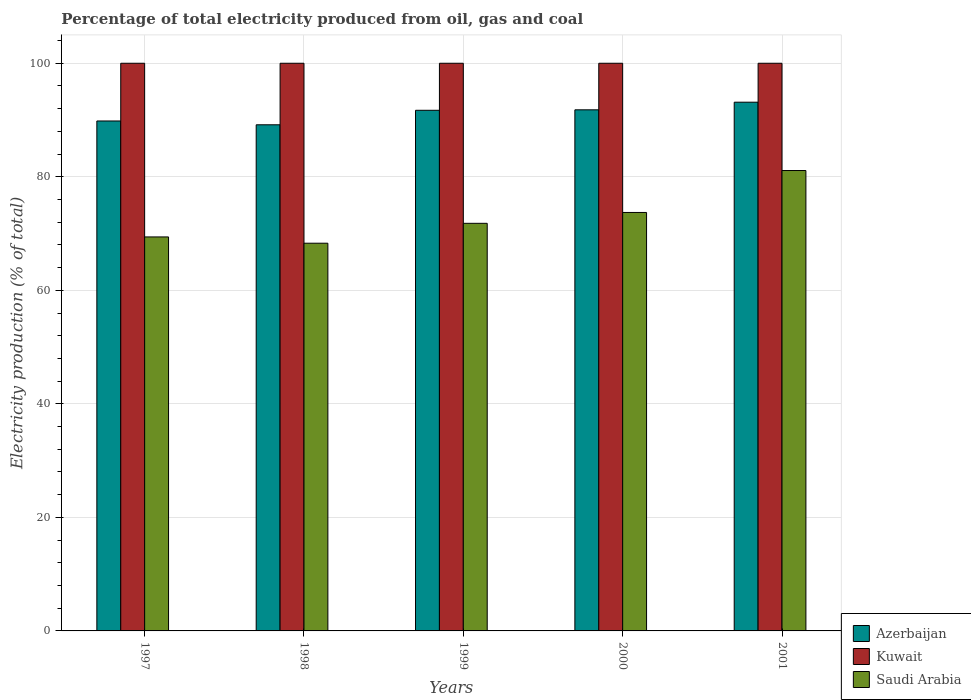How many different coloured bars are there?
Your answer should be very brief. 3. Are the number of bars on each tick of the X-axis equal?
Give a very brief answer. Yes. How many bars are there on the 2nd tick from the right?
Your answer should be compact. 3. What is the electricity production in in Azerbaijan in 1998?
Your answer should be very brief. 89.16. Across all years, what is the maximum electricity production in in Azerbaijan?
Provide a succinct answer. 93.14. Across all years, what is the minimum electricity production in in Azerbaijan?
Your answer should be very brief. 89.16. In which year was the electricity production in in Saudi Arabia maximum?
Give a very brief answer. 2001. In which year was the electricity production in in Azerbaijan minimum?
Your answer should be very brief. 1998. What is the total electricity production in in Saudi Arabia in the graph?
Offer a terse response. 364.33. What is the difference between the electricity production in in Saudi Arabia in 1997 and that in 1998?
Keep it short and to the point. 1.11. What is the difference between the electricity production in in Saudi Arabia in 1997 and the electricity production in in Azerbaijan in 1999?
Your response must be concise. -22.31. In the year 2000, what is the difference between the electricity production in in Azerbaijan and electricity production in in Saudi Arabia?
Ensure brevity in your answer.  18.08. In how many years, is the electricity production in in Saudi Arabia greater than 60 %?
Give a very brief answer. 5. What is the ratio of the electricity production in in Azerbaijan in 1999 to that in 2001?
Make the answer very short. 0.98. Is the difference between the electricity production in in Azerbaijan in 1999 and 2001 greater than the difference between the electricity production in in Saudi Arabia in 1999 and 2001?
Make the answer very short. Yes. What is the difference between the highest and the second highest electricity production in in Saudi Arabia?
Ensure brevity in your answer.  7.39. What is the difference between the highest and the lowest electricity production in in Kuwait?
Offer a terse response. 0. In how many years, is the electricity production in in Azerbaijan greater than the average electricity production in in Azerbaijan taken over all years?
Offer a very short reply. 3. What does the 3rd bar from the left in 1998 represents?
Your answer should be very brief. Saudi Arabia. What does the 2nd bar from the right in 2001 represents?
Keep it short and to the point. Kuwait. How many bars are there?
Ensure brevity in your answer.  15. How many years are there in the graph?
Make the answer very short. 5. Does the graph contain any zero values?
Provide a succinct answer. No. Does the graph contain grids?
Ensure brevity in your answer.  Yes. How are the legend labels stacked?
Offer a very short reply. Vertical. What is the title of the graph?
Your response must be concise. Percentage of total electricity produced from oil, gas and coal. What is the label or title of the X-axis?
Make the answer very short. Years. What is the label or title of the Y-axis?
Make the answer very short. Electricity production (% of total). What is the Electricity production (% of total) in Azerbaijan in 1997?
Ensure brevity in your answer.  89.83. What is the Electricity production (% of total) of Saudi Arabia in 1997?
Make the answer very short. 69.41. What is the Electricity production (% of total) of Azerbaijan in 1998?
Provide a short and direct response. 89.16. What is the Electricity production (% of total) in Saudi Arabia in 1998?
Make the answer very short. 68.3. What is the Electricity production (% of total) of Azerbaijan in 1999?
Offer a terse response. 91.71. What is the Electricity production (% of total) in Saudi Arabia in 1999?
Provide a short and direct response. 71.8. What is the Electricity production (% of total) in Azerbaijan in 2000?
Your response must be concise. 91.8. What is the Electricity production (% of total) in Kuwait in 2000?
Offer a very short reply. 100. What is the Electricity production (% of total) of Saudi Arabia in 2000?
Ensure brevity in your answer.  73.72. What is the Electricity production (% of total) of Azerbaijan in 2001?
Your response must be concise. 93.14. What is the Electricity production (% of total) in Saudi Arabia in 2001?
Keep it short and to the point. 81.11. Across all years, what is the maximum Electricity production (% of total) of Azerbaijan?
Give a very brief answer. 93.14. Across all years, what is the maximum Electricity production (% of total) in Kuwait?
Your response must be concise. 100. Across all years, what is the maximum Electricity production (% of total) of Saudi Arabia?
Offer a very short reply. 81.11. Across all years, what is the minimum Electricity production (% of total) in Azerbaijan?
Offer a very short reply. 89.16. Across all years, what is the minimum Electricity production (% of total) of Saudi Arabia?
Your answer should be very brief. 68.3. What is the total Electricity production (% of total) of Azerbaijan in the graph?
Give a very brief answer. 455.64. What is the total Electricity production (% of total) in Saudi Arabia in the graph?
Your answer should be compact. 364.33. What is the difference between the Electricity production (% of total) in Azerbaijan in 1997 and that in 1998?
Your answer should be very brief. 0.67. What is the difference between the Electricity production (% of total) of Saudi Arabia in 1997 and that in 1998?
Your answer should be compact. 1.11. What is the difference between the Electricity production (% of total) of Azerbaijan in 1997 and that in 1999?
Keep it short and to the point. -1.88. What is the difference between the Electricity production (% of total) in Kuwait in 1997 and that in 1999?
Your answer should be compact. 0. What is the difference between the Electricity production (% of total) in Saudi Arabia in 1997 and that in 1999?
Keep it short and to the point. -2.4. What is the difference between the Electricity production (% of total) in Azerbaijan in 1997 and that in 2000?
Make the answer very short. -1.97. What is the difference between the Electricity production (% of total) in Kuwait in 1997 and that in 2000?
Offer a terse response. 0. What is the difference between the Electricity production (% of total) in Saudi Arabia in 1997 and that in 2000?
Your response must be concise. -4.31. What is the difference between the Electricity production (% of total) in Azerbaijan in 1997 and that in 2001?
Give a very brief answer. -3.31. What is the difference between the Electricity production (% of total) of Saudi Arabia in 1997 and that in 2001?
Your response must be concise. -11.7. What is the difference between the Electricity production (% of total) in Azerbaijan in 1998 and that in 1999?
Ensure brevity in your answer.  -2.55. What is the difference between the Electricity production (% of total) in Kuwait in 1998 and that in 1999?
Your answer should be compact. 0. What is the difference between the Electricity production (% of total) in Saudi Arabia in 1998 and that in 1999?
Offer a terse response. -3.5. What is the difference between the Electricity production (% of total) of Azerbaijan in 1998 and that in 2000?
Offer a terse response. -2.64. What is the difference between the Electricity production (% of total) of Kuwait in 1998 and that in 2000?
Keep it short and to the point. 0. What is the difference between the Electricity production (% of total) of Saudi Arabia in 1998 and that in 2000?
Your answer should be compact. -5.41. What is the difference between the Electricity production (% of total) of Azerbaijan in 1998 and that in 2001?
Offer a terse response. -3.98. What is the difference between the Electricity production (% of total) of Kuwait in 1998 and that in 2001?
Offer a terse response. 0. What is the difference between the Electricity production (% of total) of Saudi Arabia in 1998 and that in 2001?
Provide a short and direct response. -12.8. What is the difference between the Electricity production (% of total) of Azerbaijan in 1999 and that in 2000?
Make the answer very short. -0.08. What is the difference between the Electricity production (% of total) in Saudi Arabia in 1999 and that in 2000?
Your answer should be very brief. -1.91. What is the difference between the Electricity production (% of total) in Azerbaijan in 1999 and that in 2001?
Your answer should be very brief. -1.43. What is the difference between the Electricity production (% of total) of Kuwait in 1999 and that in 2001?
Your answer should be very brief. 0. What is the difference between the Electricity production (% of total) in Saudi Arabia in 1999 and that in 2001?
Make the answer very short. -9.3. What is the difference between the Electricity production (% of total) of Azerbaijan in 2000 and that in 2001?
Your response must be concise. -1.35. What is the difference between the Electricity production (% of total) of Saudi Arabia in 2000 and that in 2001?
Offer a terse response. -7.39. What is the difference between the Electricity production (% of total) of Azerbaijan in 1997 and the Electricity production (% of total) of Kuwait in 1998?
Provide a succinct answer. -10.17. What is the difference between the Electricity production (% of total) of Azerbaijan in 1997 and the Electricity production (% of total) of Saudi Arabia in 1998?
Make the answer very short. 21.53. What is the difference between the Electricity production (% of total) in Kuwait in 1997 and the Electricity production (% of total) in Saudi Arabia in 1998?
Make the answer very short. 31.7. What is the difference between the Electricity production (% of total) in Azerbaijan in 1997 and the Electricity production (% of total) in Kuwait in 1999?
Give a very brief answer. -10.17. What is the difference between the Electricity production (% of total) of Azerbaijan in 1997 and the Electricity production (% of total) of Saudi Arabia in 1999?
Make the answer very short. 18.03. What is the difference between the Electricity production (% of total) of Kuwait in 1997 and the Electricity production (% of total) of Saudi Arabia in 1999?
Offer a terse response. 28.2. What is the difference between the Electricity production (% of total) of Azerbaijan in 1997 and the Electricity production (% of total) of Kuwait in 2000?
Your answer should be compact. -10.17. What is the difference between the Electricity production (% of total) in Azerbaijan in 1997 and the Electricity production (% of total) in Saudi Arabia in 2000?
Offer a terse response. 16.12. What is the difference between the Electricity production (% of total) in Kuwait in 1997 and the Electricity production (% of total) in Saudi Arabia in 2000?
Provide a short and direct response. 26.28. What is the difference between the Electricity production (% of total) of Azerbaijan in 1997 and the Electricity production (% of total) of Kuwait in 2001?
Offer a terse response. -10.17. What is the difference between the Electricity production (% of total) in Azerbaijan in 1997 and the Electricity production (% of total) in Saudi Arabia in 2001?
Your answer should be compact. 8.73. What is the difference between the Electricity production (% of total) of Kuwait in 1997 and the Electricity production (% of total) of Saudi Arabia in 2001?
Give a very brief answer. 18.89. What is the difference between the Electricity production (% of total) in Azerbaijan in 1998 and the Electricity production (% of total) in Kuwait in 1999?
Provide a short and direct response. -10.84. What is the difference between the Electricity production (% of total) in Azerbaijan in 1998 and the Electricity production (% of total) in Saudi Arabia in 1999?
Ensure brevity in your answer.  17.36. What is the difference between the Electricity production (% of total) in Kuwait in 1998 and the Electricity production (% of total) in Saudi Arabia in 1999?
Give a very brief answer. 28.2. What is the difference between the Electricity production (% of total) of Azerbaijan in 1998 and the Electricity production (% of total) of Kuwait in 2000?
Your answer should be very brief. -10.84. What is the difference between the Electricity production (% of total) in Azerbaijan in 1998 and the Electricity production (% of total) in Saudi Arabia in 2000?
Ensure brevity in your answer.  15.44. What is the difference between the Electricity production (% of total) of Kuwait in 1998 and the Electricity production (% of total) of Saudi Arabia in 2000?
Your answer should be very brief. 26.28. What is the difference between the Electricity production (% of total) in Azerbaijan in 1998 and the Electricity production (% of total) in Kuwait in 2001?
Provide a short and direct response. -10.84. What is the difference between the Electricity production (% of total) of Azerbaijan in 1998 and the Electricity production (% of total) of Saudi Arabia in 2001?
Your answer should be very brief. 8.05. What is the difference between the Electricity production (% of total) of Kuwait in 1998 and the Electricity production (% of total) of Saudi Arabia in 2001?
Offer a very short reply. 18.89. What is the difference between the Electricity production (% of total) in Azerbaijan in 1999 and the Electricity production (% of total) in Kuwait in 2000?
Offer a terse response. -8.29. What is the difference between the Electricity production (% of total) in Azerbaijan in 1999 and the Electricity production (% of total) in Saudi Arabia in 2000?
Your answer should be compact. 18. What is the difference between the Electricity production (% of total) in Kuwait in 1999 and the Electricity production (% of total) in Saudi Arabia in 2000?
Make the answer very short. 26.28. What is the difference between the Electricity production (% of total) in Azerbaijan in 1999 and the Electricity production (% of total) in Kuwait in 2001?
Your answer should be very brief. -8.29. What is the difference between the Electricity production (% of total) of Azerbaijan in 1999 and the Electricity production (% of total) of Saudi Arabia in 2001?
Offer a very short reply. 10.61. What is the difference between the Electricity production (% of total) of Kuwait in 1999 and the Electricity production (% of total) of Saudi Arabia in 2001?
Your answer should be compact. 18.89. What is the difference between the Electricity production (% of total) in Azerbaijan in 2000 and the Electricity production (% of total) in Kuwait in 2001?
Offer a terse response. -8.2. What is the difference between the Electricity production (% of total) of Azerbaijan in 2000 and the Electricity production (% of total) of Saudi Arabia in 2001?
Offer a terse response. 10.69. What is the difference between the Electricity production (% of total) of Kuwait in 2000 and the Electricity production (% of total) of Saudi Arabia in 2001?
Ensure brevity in your answer.  18.89. What is the average Electricity production (% of total) of Azerbaijan per year?
Provide a short and direct response. 91.13. What is the average Electricity production (% of total) of Kuwait per year?
Offer a terse response. 100. What is the average Electricity production (% of total) in Saudi Arabia per year?
Keep it short and to the point. 72.87. In the year 1997, what is the difference between the Electricity production (% of total) in Azerbaijan and Electricity production (% of total) in Kuwait?
Provide a succinct answer. -10.17. In the year 1997, what is the difference between the Electricity production (% of total) of Azerbaijan and Electricity production (% of total) of Saudi Arabia?
Give a very brief answer. 20.43. In the year 1997, what is the difference between the Electricity production (% of total) of Kuwait and Electricity production (% of total) of Saudi Arabia?
Keep it short and to the point. 30.59. In the year 1998, what is the difference between the Electricity production (% of total) of Azerbaijan and Electricity production (% of total) of Kuwait?
Offer a terse response. -10.84. In the year 1998, what is the difference between the Electricity production (% of total) of Azerbaijan and Electricity production (% of total) of Saudi Arabia?
Provide a short and direct response. 20.86. In the year 1998, what is the difference between the Electricity production (% of total) of Kuwait and Electricity production (% of total) of Saudi Arabia?
Your answer should be very brief. 31.7. In the year 1999, what is the difference between the Electricity production (% of total) of Azerbaijan and Electricity production (% of total) of Kuwait?
Give a very brief answer. -8.29. In the year 1999, what is the difference between the Electricity production (% of total) of Azerbaijan and Electricity production (% of total) of Saudi Arabia?
Your answer should be compact. 19.91. In the year 1999, what is the difference between the Electricity production (% of total) of Kuwait and Electricity production (% of total) of Saudi Arabia?
Offer a terse response. 28.2. In the year 2000, what is the difference between the Electricity production (% of total) of Azerbaijan and Electricity production (% of total) of Kuwait?
Provide a short and direct response. -8.2. In the year 2000, what is the difference between the Electricity production (% of total) in Azerbaijan and Electricity production (% of total) in Saudi Arabia?
Offer a very short reply. 18.08. In the year 2000, what is the difference between the Electricity production (% of total) in Kuwait and Electricity production (% of total) in Saudi Arabia?
Give a very brief answer. 26.28. In the year 2001, what is the difference between the Electricity production (% of total) in Azerbaijan and Electricity production (% of total) in Kuwait?
Offer a terse response. -6.86. In the year 2001, what is the difference between the Electricity production (% of total) in Azerbaijan and Electricity production (% of total) in Saudi Arabia?
Keep it short and to the point. 12.04. In the year 2001, what is the difference between the Electricity production (% of total) of Kuwait and Electricity production (% of total) of Saudi Arabia?
Provide a succinct answer. 18.89. What is the ratio of the Electricity production (% of total) in Azerbaijan in 1997 to that in 1998?
Provide a short and direct response. 1.01. What is the ratio of the Electricity production (% of total) in Kuwait in 1997 to that in 1998?
Offer a very short reply. 1. What is the ratio of the Electricity production (% of total) of Saudi Arabia in 1997 to that in 1998?
Your answer should be compact. 1.02. What is the ratio of the Electricity production (% of total) in Azerbaijan in 1997 to that in 1999?
Ensure brevity in your answer.  0.98. What is the ratio of the Electricity production (% of total) of Kuwait in 1997 to that in 1999?
Provide a succinct answer. 1. What is the ratio of the Electricity production (% of total) in Saudi Arabia in 1997 to that in 1999?
Make the answer very short. 0.97. What is the ratio of the Electricity production (% of total) in Azerbaijan in 1997 to that in 2000?
Your response must be concise. 0.98. What is the ratio of the Electricity production (% of total) in Saudi Arabia in 1997 to that in 2000?
Provide a short and direct response. 0.94. What is the ratio of the Electricity production (% of total) in Azerbaijan in 1997 to that in 2001?
Keep it short and to the point. 0.96. What is the ratio of the Electricity production (% of total) of Saudi Arabia in 1997 to that in 2001?
Provide a short and direct response. 0.86. What is the ratio of the Electricity production (% of total) in Azerbaijan in 1998 to that in 1999?
Your response must be concise. 0.97. What is the ratio of the Electricity production (% of total) in Saudi Arabia in 1998 to that in 1999?
Your response must be concise. 0.95. What is the ratio of the Electricity production (% of total) of Azerbaijan in 1998 to that in 2000?
Give a very brief answer. 0.97. What is the ratio of the Electricity production (% of total) of Kuwait in 1998 to that in 2000?
Offer a terse response. 1. What is the ratio of the Electricity production (% of total) in Saudi Arabia in 1998 to that in 2000?
Your response must be concise. 0.93. What is the ratio of the Electricity production (% of total) of Azerbaijan in 1998 to that in 2001?
Offer a very short reply. 0.96. What is the ratio of the Electricity production (% of total) of Kuwait in 1998 to that in 2001?
Ensure brevity in your answer.  1. What is the ratio of the Electricity production (% of total) in Saudi Arabia in 1998 to that in 2001?
Offer a terse response. 0.84. What is the ratio of the Electricity production (% of total) of Saudi Arabia in 1999 to that in 2000?
Provide a short and direct response. 0.97. What is the ratio of the Electricity production (% of total) in Azerbaijan in 1999 to that in 2001?
Your answer should be very brief. 0.98. What is the ratio of the Electricity production (% of total) in Saudi Arabia in 1999 to that in 2001?
Keep it short and to the point. 0.89. What is the ratio of the Electricity production (% of total) in Azerbaijan in 2000 to that in 2001?
Ensure brevity in your answer.  0.99. What is the ratio of the Electricity production (% of total) of Kuwait in 2000 to that in 2001?
Provide a short and direct response. 1. What is the ratio of the Electricity production (% of total) in Saudi Arabia in 2000 to that in 2001?
Offer a very short reply. 0.91. What is the difference between the highest and the second highest Electricity production (% of total) in Azerbaijan?
Offer a very short reply. 1.35. What is the difference between the highest and the second highest Electricity production (% of total) in Saudi Arabia?
Your response must be concise. 7.39. What is the difference between the highest and the lowest Electricity production (% of total) of Azerbaijan?
Offer a very short reply. 3.98. What is the difference between the highest and the lowest Electricity production (% of total) in Saudi Arabia?
Provide a short and direct response. 12.8. 